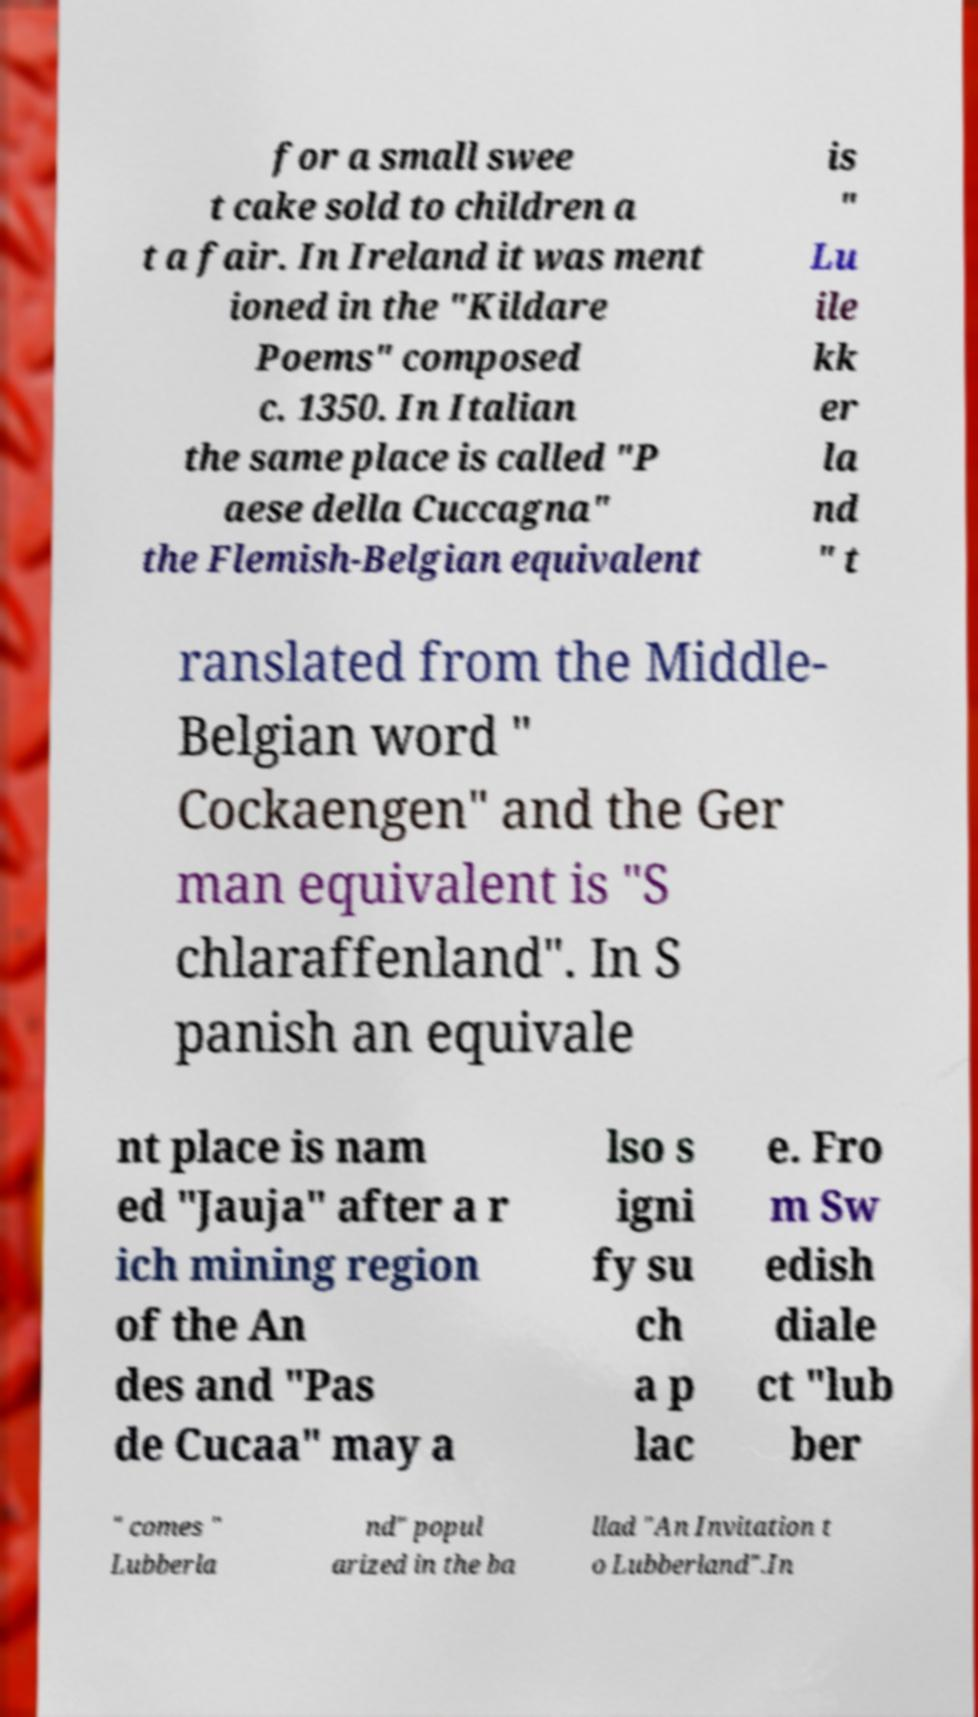For documentation purposes, I need the text within this image transcribed. Could you provide that? for a small swee t cake sold to children a t a fair. In Ireland it was ment ioned in the "Kildare Poems" composed c. 1350. In Italian the same place is called "P aese della Cuccagna" the Flemish-Belgian equivalent is " Lu ile kk er la nd " t ranslated from the Middle- Belgian word " Cockaengen" and the Ger man equivalent is "S chlaraffenland". In S panish an equivale nt place is nam ed "Jauja" after a r ich mining region of the An des and "Pas de Cucaa" may a lso s igni fy su ch a p lac e. Fro m Sw edish diale ct "lub ber " comes " Lubberla nd" popul arized in the ba llad "An Invitation t o Lubberland".In 